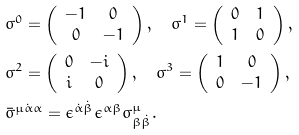<formula> <loc_0><loc_0><loc_500><loc_500>& \sigma ^ { 0 } = \left ( \begin{array} { c c } - 1 & 0 \\ 0 & - 1 \end{array} \right ) , \quad \sigma ^ { 1 } = \left ( \begin{array} { c c } 0 & 1 \\ 1 & 0 \end{array} \right ) , \\ & \sigma ^ { 2 } = \left ( \begin{array} { c c } 0 & - i \\ i & 0 \end{array} \right ) , \quad \sigma ^ { 3 } = \left ( \begin{array} { c c } 1 & 0 \\ 0 & - 1 \end{array} \right ) , \\ & \bar { \sigma } ^ { \mu \dot { \alpha } \alpha } = \epsilon ^ { \dot { \alpha } \dot { \beta } } \epsilon ^ { \alpha \beta } \sigma ^ { \mu } _ { \beta \dot { \beta } } .</formula> 